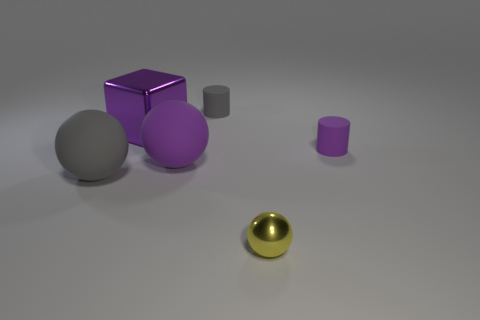What shape is the large object behind the big sphere that is right of the big metal object?
Provide a succinct answer. Cube. Is there a gray thing of the same shape as the tiny purple object?
Make the answer very short. Yes. There is a cube; does it have the same color as the metal object on the right side of the big purple sphere?
Your answer should be compact. No. There is a sphere that is the same color as the block; what is its size?
Your response must be concise. Large. Are there any gray spheres that have the same size as the yellow object?
Your response must be concise. No. Does the small yellow thing have the same material as the cylinder behind the large purple block?
Give a very brief answer. No. Is the number of small brown metal cylinders greater than the number of tiny rubber things?
Your answer should be compact. No. How many balls are either large objects or small rubber things?
Offer a terse response. 2. What is the color of the small sphere?
Ensure brevity in your answer.  Yellow. Does the matte object right of the yellow object have the same size as the cylinder behind the cube?
Your answer should be compact. Yes. 